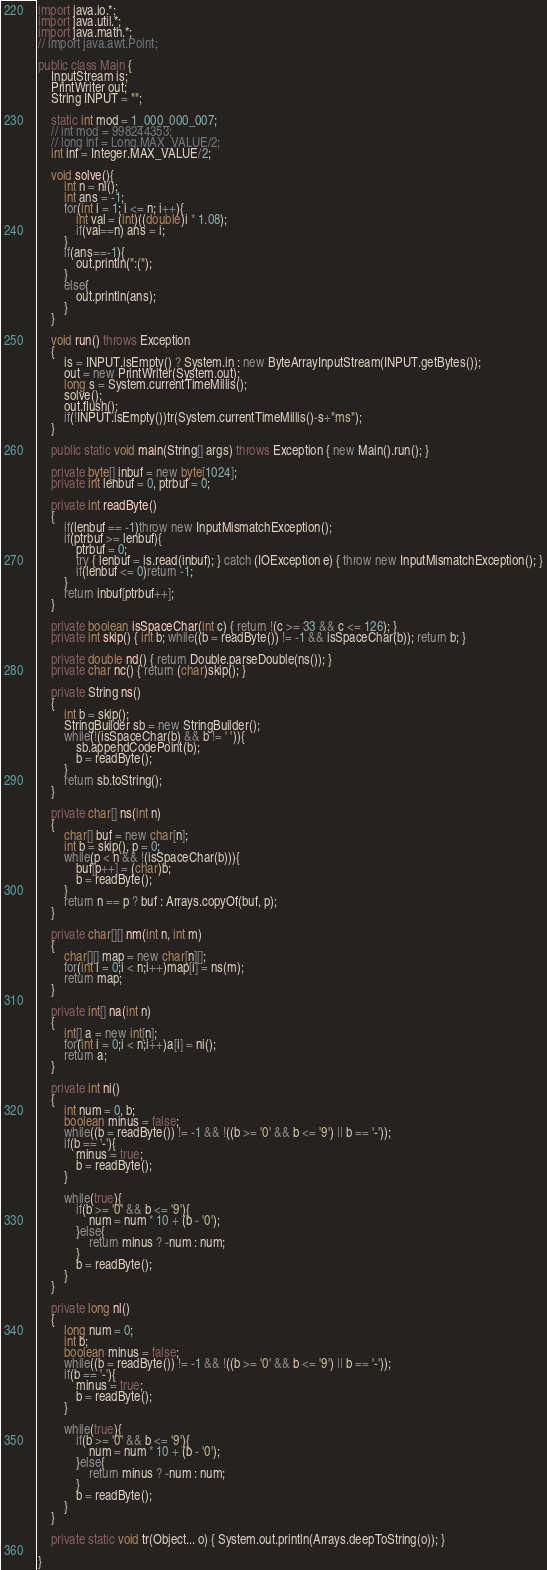Convert code to text. <code><loc_0><loc_0><loc_500><loc_500><_Java_>import java.io.*;
import java.util.*;
import java.math.*;
// import java.awt.Point;
 
public class Main {
    InputStream is;
    PrintWriter out;
    String INPUT = "";
 
    static int mod = 1_000_000_007;
    // int mod = 998244353;
    // long inf = Long.MAX_VALUE/2;
    int inf = Integer.MAX_VALUE/2;

    void solve(){
        int n = ni();
        int ans = -1;
        for(int i = 1; i <= n; i++){
            int val = (int)((double)i * 1.08);
            if(val==n) ans = i;
        }
        if(ans==-1){
            out.println(":(");
        }
        else{
            out.println(ans);
        }
    }

    void run() throws Exception
    {
        is = INPUT.isEmpty() ? System.in : new ByteArrayInputStream(INPUT.getBytes());
        out = new PrintWriter(System.out);
        long s = System.currentTimeMillis();
        solve();
        out.flush();
        if(!INPUT.isEmpty())tr(System.currentTimeMillis()-s+"ms");
    }
    
    public static void main(String[] args) throws Exception { new Main().run(); }
    
    private byte[] inbuf = new byte[1024];
    private int lenbuf = 0, ptrbuf = 0;
    
    private int readByte()
    {
        if(lenbuf == -1)throw new InputMismatchException();
        if(ptrbuf >= lenbuf){
            ptrbuf = 0;
            try { lenbuf = is.read(inbuf); } catch (IOException e) { throw new InputMismatchException(); }
            if(lenbuf <= 0)return -1;
        }
        return inbuf[ptrbuf++];
    }
    
    private boolean isSpaceChar(int c) { return !(c >= 33 && c <= 126); }
    private int skip() { int b; while((b = readByte()) != -1 && isSpaceChar(b)); return b; }
    
    private double nd() { return Double.parseDouble(ns()); }
    private char nc() { return (char)skip(); }
    
    private String ns()
    {
        int b = skip();
        StringBuilder sb = new StringBuilder();
        while(!(isSpaceChar(b) && b != ' ')){
            sb.appendCodePoint(b);
            b = readByte();
        }
        return sb.toString();
    }
    
    private char[] ns(int n)
    {
        char[] buf = new char[n];
        int b = skip(), p = 0;
        while(p < n && !(isSpaceChar(b))){
            buf[p++] = (char)b;
            b = readByte();
        }
        return n == p ? buf : Arrays.copyOf(buf, p);
    }
    
    private char[][] nm(int n, int m)
    {
        char[][] map = new char[n][];
        for(int i = 0;i < n;i++)map[i] = ns(m);
        return map;
    }
    
    private int[] na(int n)
    {
        int[] a = new int[n];
        for(int i = 0;i < n;i++)a[i] = ni();
        return a;
    }
    
    private int ni()
    {
        int num = 0, b;
        boolean minus = false;
        while((b = readByte()) != -1 && !((b >= '0' && b <= '9') || b == '-'));
        if(b == '-'){
            minus = true;
            b = readByte();
        }
        
        while(true){
            if(b >= '0' && b <= '9'){
                num = num * 10 + (b - '0');
            }else{
                return minus ? -num : num;
            }
            b = readByte();
        }
    }
    
    private long nl()
    {
        long num = 0;
        int b;
        boolean minus = false;
        while((b = readByte()) != -1 && !((b >= '0' && b <= '9') || b == '-'));
        if(b == '-'){
            minus = true;
            b = readByte();
        }
        
        while(true){
            if(b >= '0' && b <= '9'){
                num = num * 10 + (b - '0');
            }else{
                return minus ? -num : num;
            }
            b = readByte();
        }
    }
    
    private static void tr(Object... o) { System.out.println(Arrays.deepToString(o)); }
 
}
</code> 